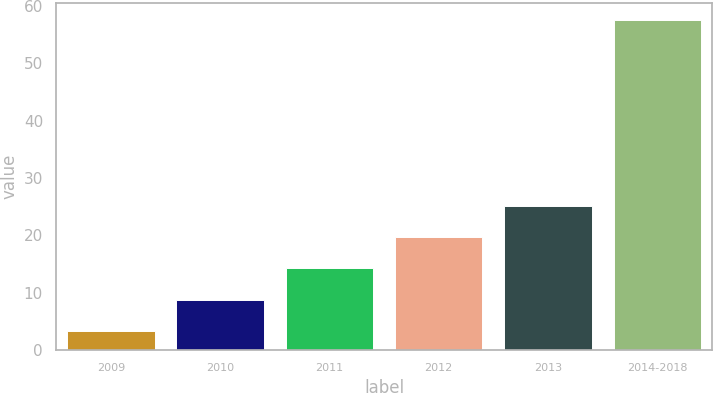Convert chart to OTSL. <chart><loc_0><loc_0><loc_500><loc_500><bar_chart><fcel>2009<fcel>2010<fcel>2011<fcel>2012<fcel>2013<fcel>2014-2018<nl><fcel>3.4<fcel>8.82<fcel>14.24<fcel>19.66<fcel>25.08<fcel>57.6<nl></chart> 